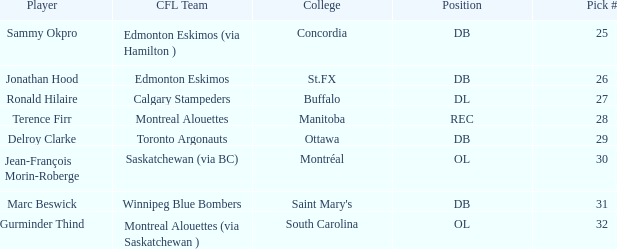Which college possesses an ol spot and a choice number below 32? Montréal. 